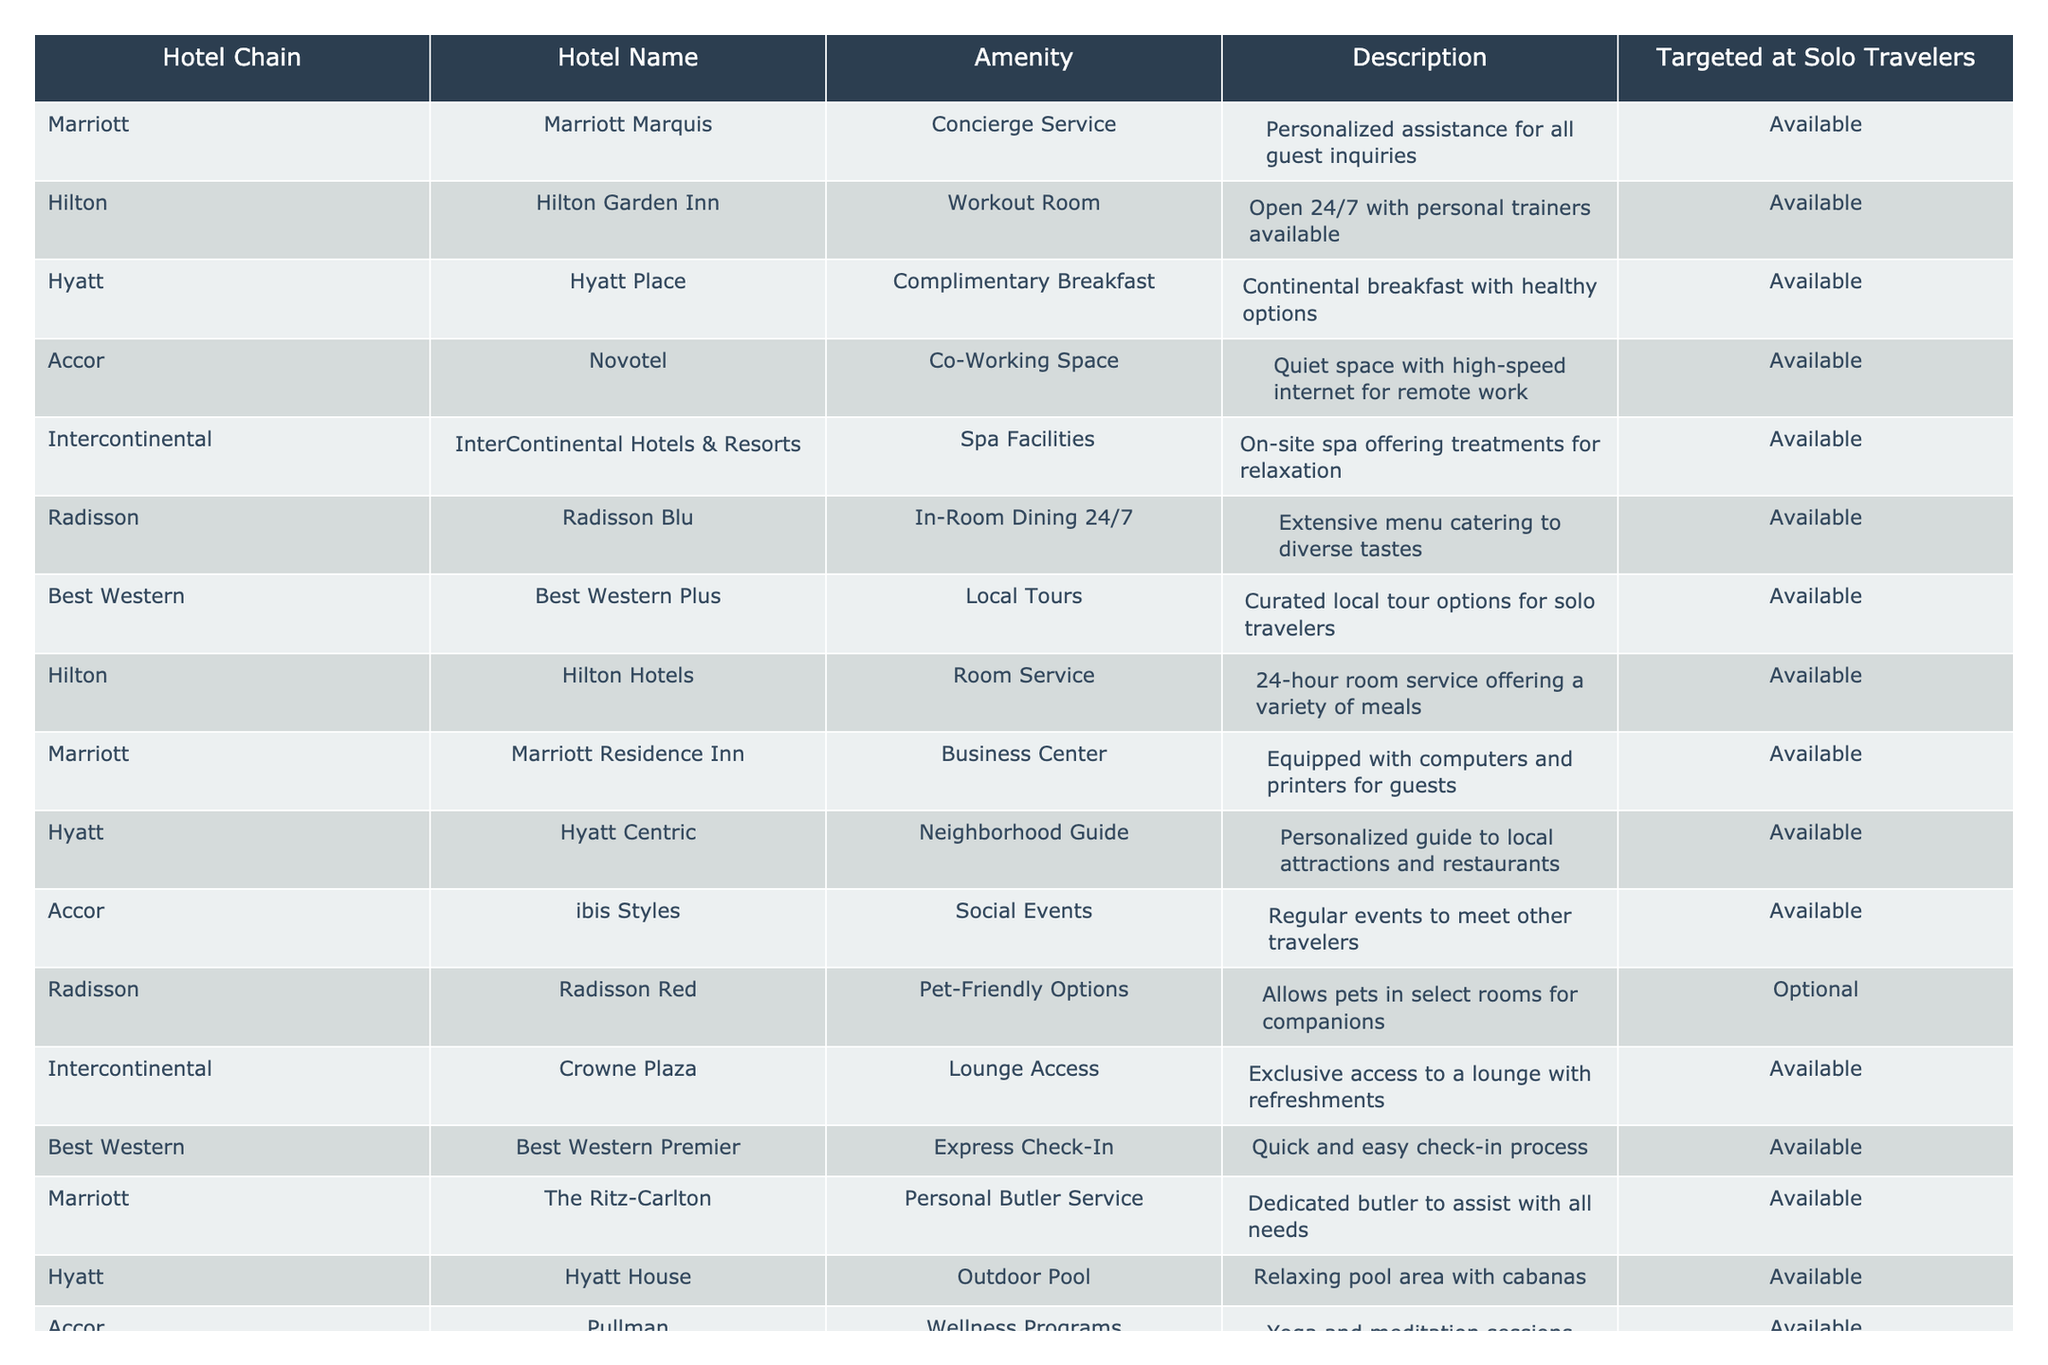What hotel chain offers a concierge service for solo travelers? The table indicates that Marriott offers concierge service at the Marriott Marquis, specifically designed for personalized assistance.
Answer: Marriott Which hotel has a wellness program available for solo travelers? According to the table, the Pullman hotel under Accor offers wellness programs that include yoga and meditation sessions, catering to solo travelers.
Answer: Pullman Does Hilton Garden Inn have a workout room available? Yes, the data shows that Hilton Garden Inn provides a workout room that is open 24/7 with personal trainers available for solo travelers.
Answer: Yes How many hotels offer a business center for solo travelers? There are two hotels offering a business center: Marriott Residence Inn and multiple other chains do not provide this amenity according to the table, which gives us a total of only one hotel with this feature.
Answer: 1 Which hotel chain provides exclusive lounge access? The table indicates that Intercontinental offers lounge access at Crowne Plaza, providing exclusive access with refreshments for solo travelers.
Answer: Intercontinental Are there any hotels that specifically target solo travelers with curated local tours? Yes, the Best Western Plus hotel offers local tours, which are specifically curated for solo travelers as indicated in the table.
Answer: Yes What is the difference in amenities between Hyatt Place and Hyatt Centric? Hyatt Place offers complimentary breakfast while Hyatt Centric provides a personalized neighborhood guide aimed at enhancing the solo travel experience.
Answer: Complimentary breakfast vs. Neighborhood guide Which hotel offers tea culture experiences as an amenity for solo travelers? The table states that Hualuxe, part of the Intercontinental chain, offers tea culture experiences, which includes unique tea ceremonies for relaxation tailored for solo travelers.
Answer: Hualuxe How many hotels have in-room dining available for solo travelers? Based on the table, there are two hotels, Radisson Blu and Hilton Hotels, that provide in-room dining available 24/7, catering to solo travelers.
Answer: 2 Does Radisson Red have any pet-friendly options? Yes, the Radisson Red hotel provides optional pet-friendly options, allowing pets in select rooms, as stated in the table.
Answer: Yes Which hotel chain has the widest variety of amenities catered to solo travelers? The table indicates that Marriott offers the widest variety with amenities like a personal butler service, concierge service, and more, specifically targeting solo travelers across its properties.
Answer: Marriott 